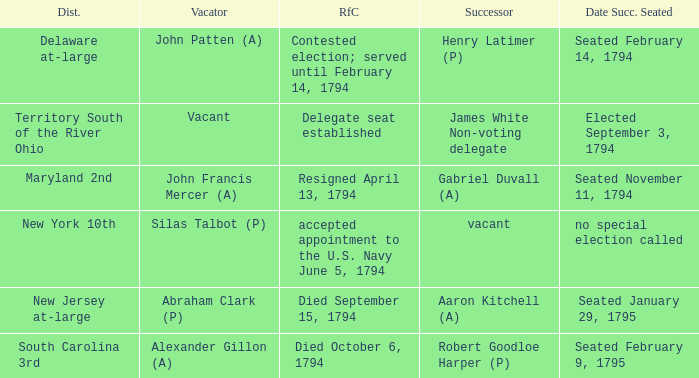Name the date successor seated is south carolina 3rd Seated February 9, 1795. 